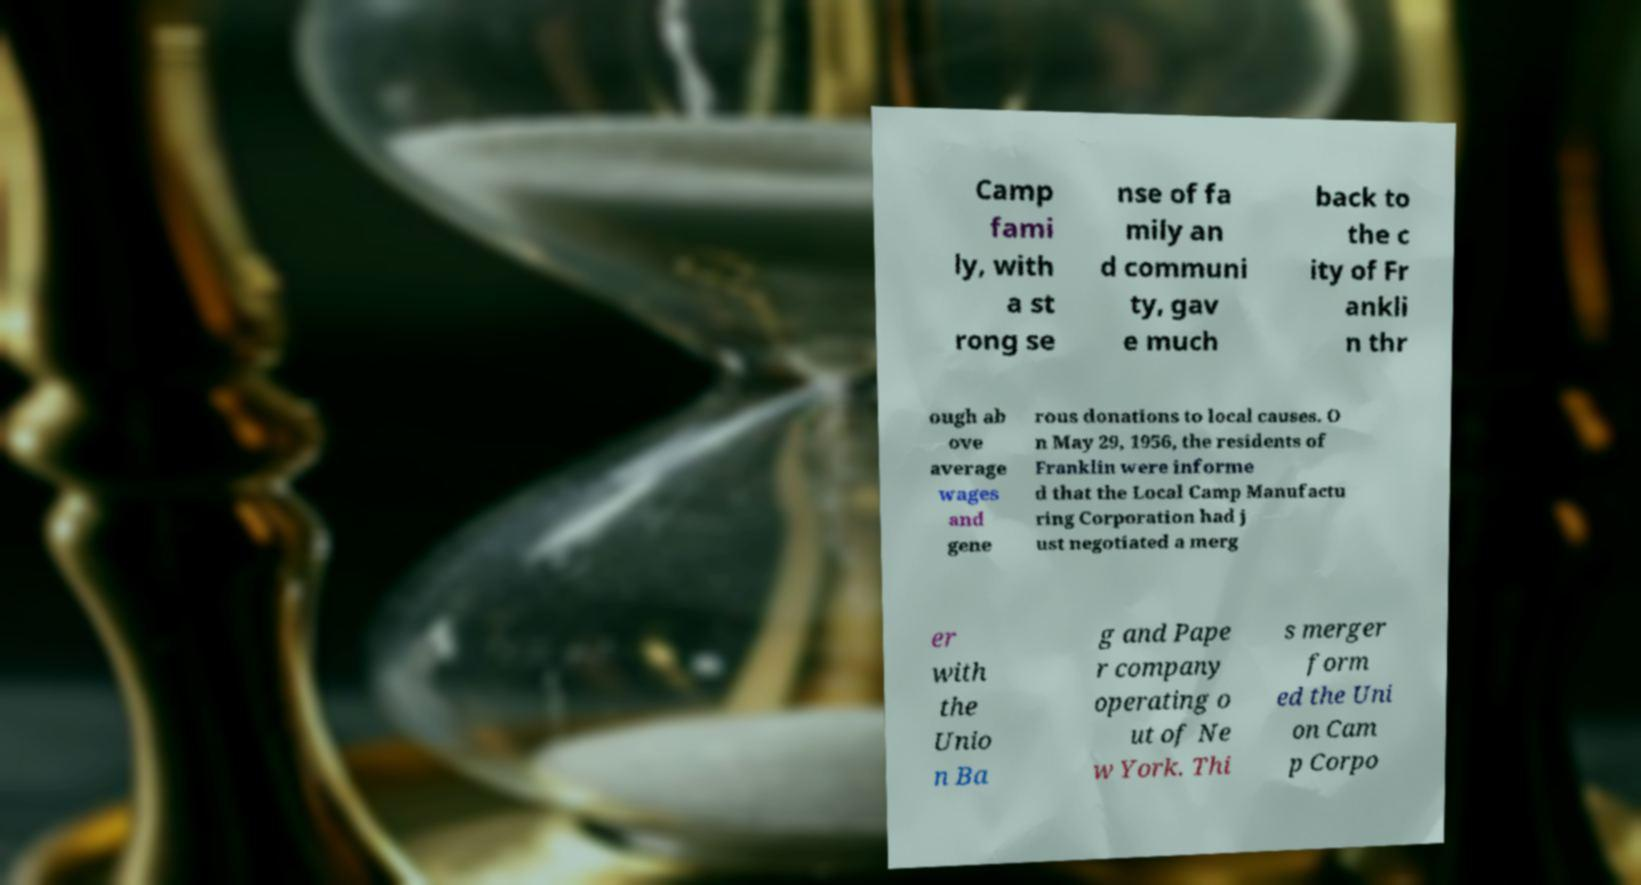Please read and relay the text visible in this image. What does it say? Camp fami ly, with a st rong se nse of fa mily an d communi ty, gav e much back to the c ity of Fr ankli n thr ough ab ove average wages and gene rous donations to local causes. O n May 29, 1956, the residents of Franklin were informe d that the Local Camp Manufactu ring Corporation had j ust negotiated a merg er with the Unio n Ba g and Pape r company operating o ut of Ne w York. Thi s merger form ed the Uni on Cam p Corpo 